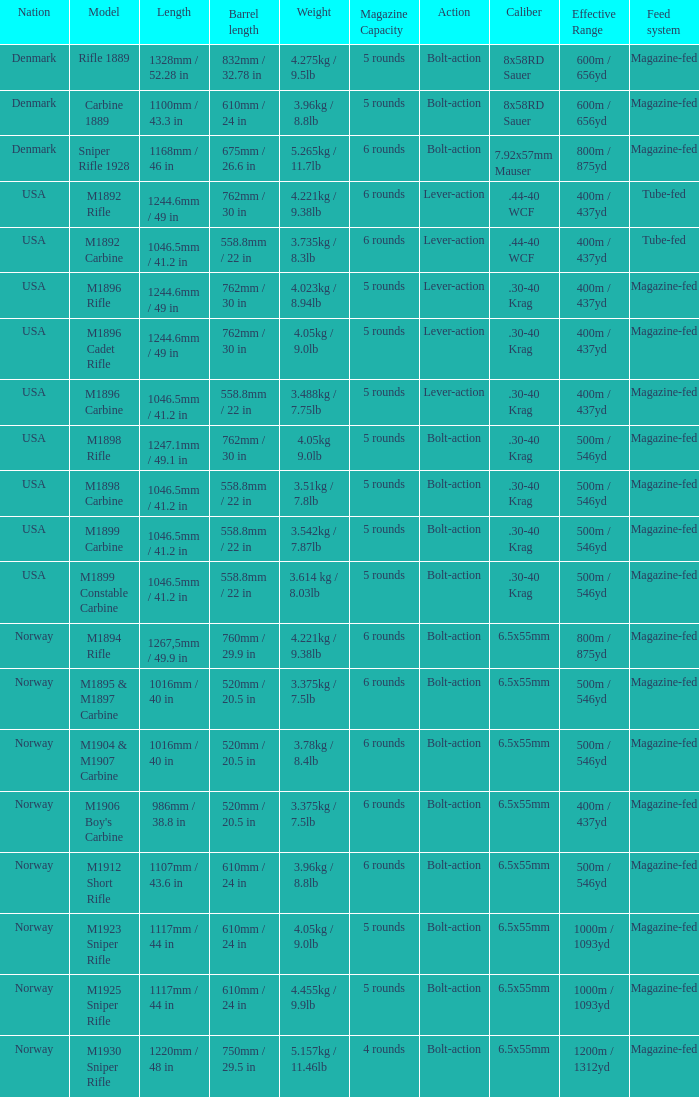What is Nation, when Model is M1895 & M1897 Carbine? Norway. 